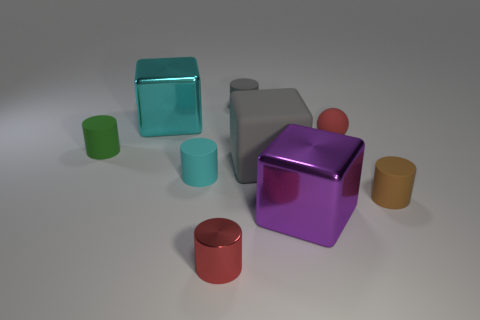Subtract all metallic cubes. How many cubes are left? 1 Subtract 3 cylinders. How many cylinders are left? 2 Subtract all cyan cylinders. How many cylinders are left? 4 Subtract all cyan cylinders. Subtract all red spheres. How many cylinders are left? 4 Subtract all cylinders. How many objects are left? 4 Subtract all big purple objects. Subtract all large gray matte blocks. How many objects are left? 7 Add 9 tiny gray matte cylinders. How many tiny gray matte cylinders are left? 10 Add 7 tiny brown rubber objects. How many tiny brown rubber objects exist? 8 Subtract 0 blue spheres. How many objects are left? 9 